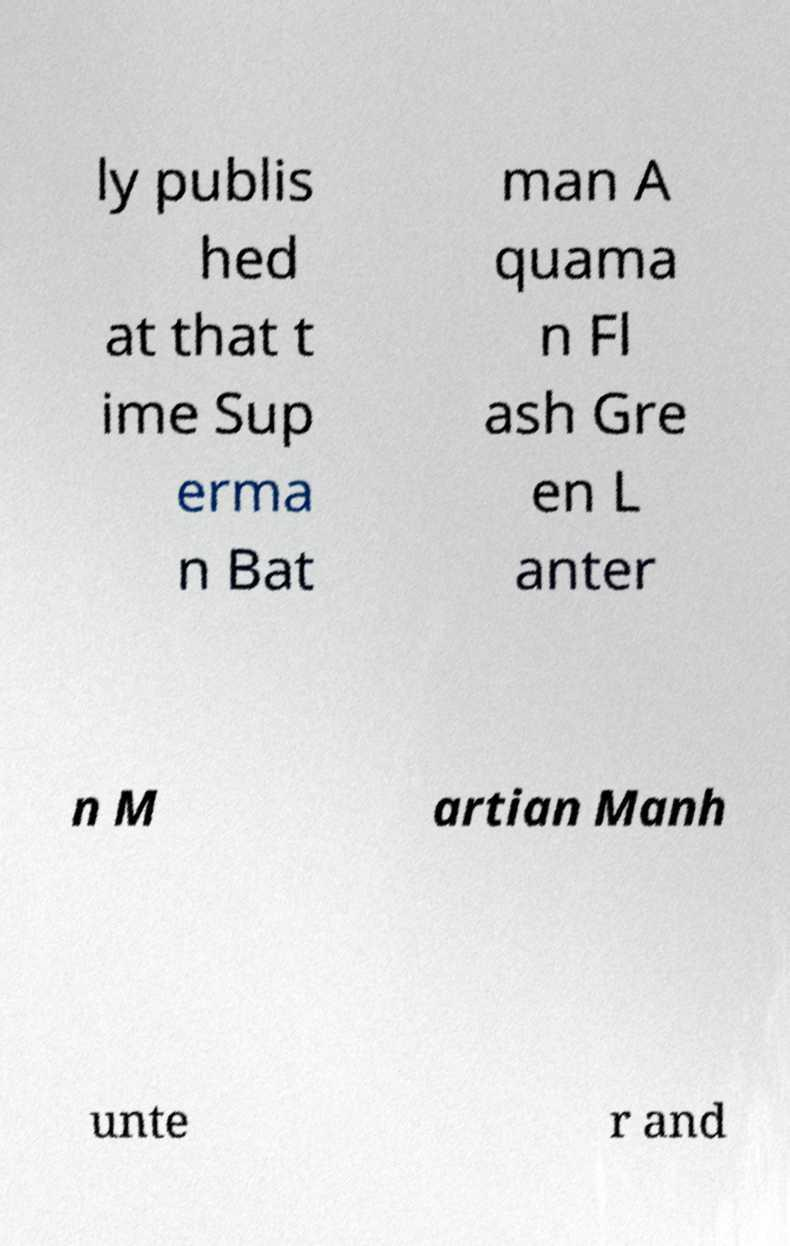Could you extract and type out the text from this image? ly publis hed at that t ime Sup erma n Bat man A quama n Fl ash Gre en L anter n M artian Manh unte r and 